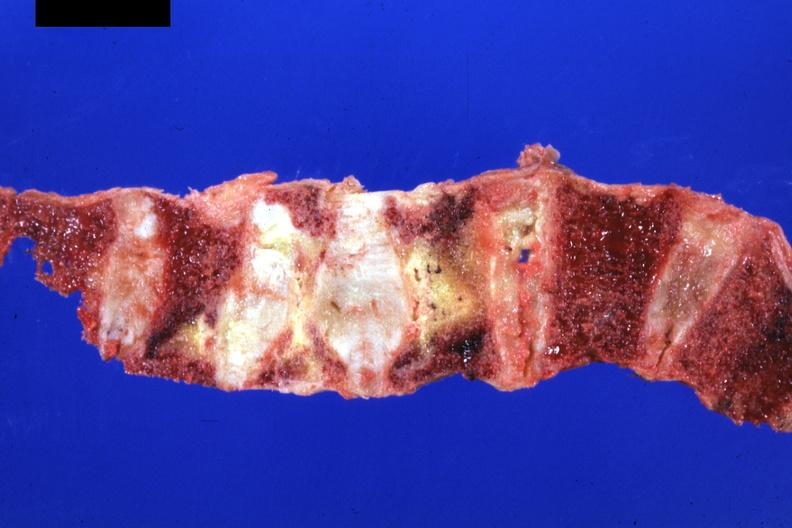what does this image show?
Answer the question using a single word or phrase. Good representation 